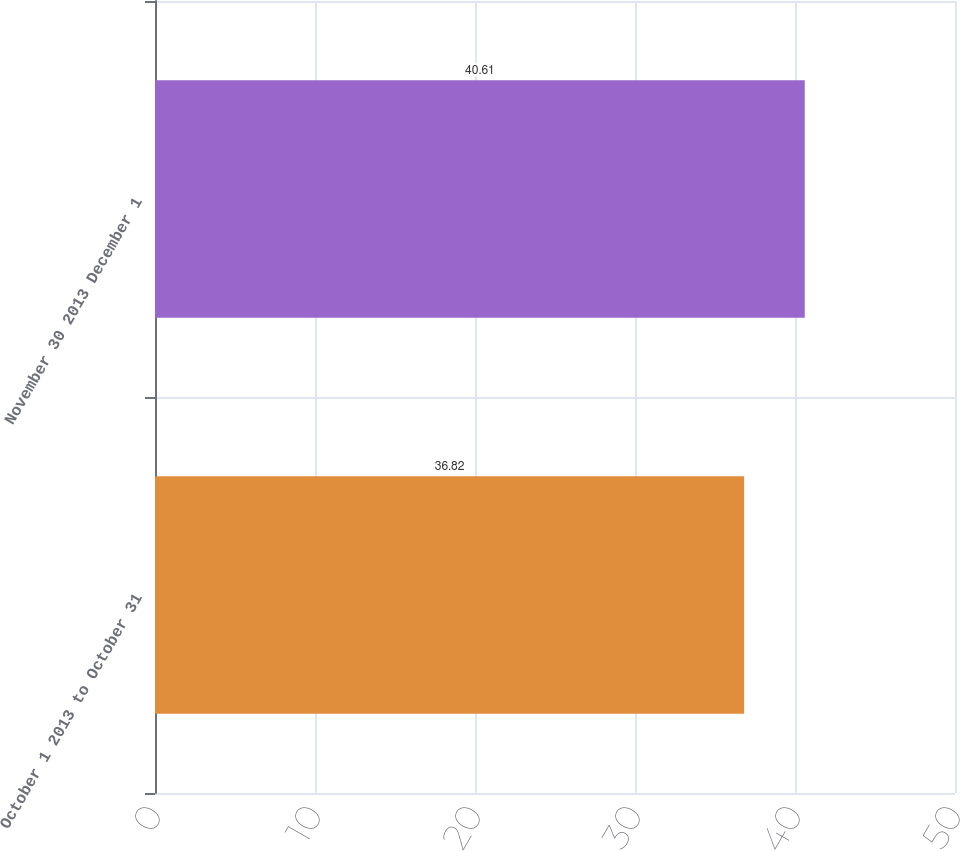Convert chart. <chart><loc_0><loc_0><loc_500><loc_500><bar_chart><fcel>October 1 2013 to October 31<fcel>November 30 2013 December 1<nl><fcel>36.82<fcel>40.61<nl></chart> 